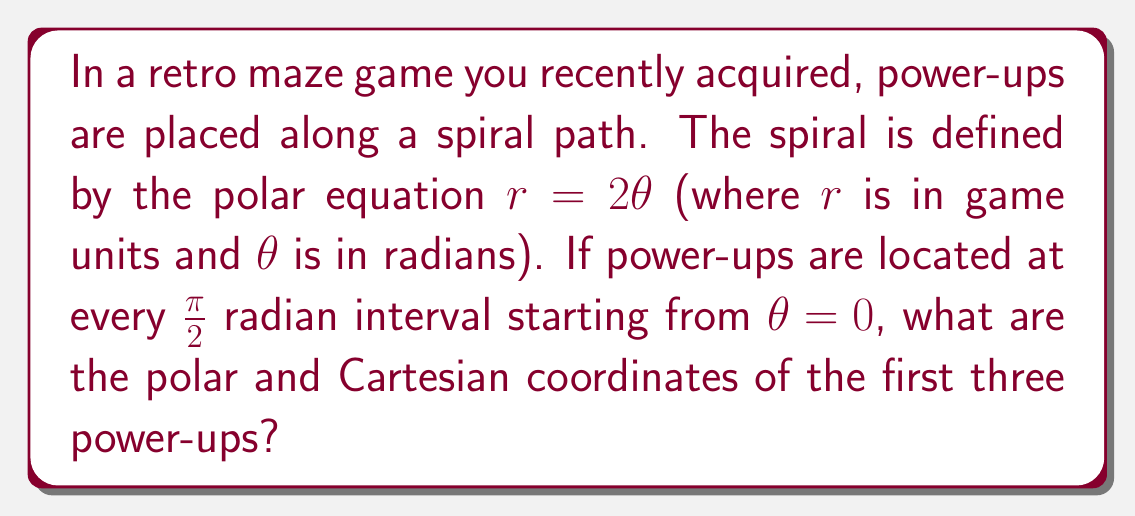Help me with this question. To solve this problem, we'll follow these steps:

1) First, we'll find the polar coordinates $(r, \theta)$ for each power-up:

   - For the first power-up: $\theta_1 = 0$
   - For the second power-up: $\theta_2 = \frac{\pi}{2}$
   - For the third power-up: $\theta_3 = \pi$

2) We'll use the equation $r = 2\theta$ to find the corresponding $r$ values:

   - For $\theta_1 = 0$: $r_1 = 2(0) = 0$
   - For $\theta_2 = \frac{\pi}{2}$: $r_2 = 2(\frac{\pi}{2}) = \pi$
   - For $\theta_3 = \pi$: $r_3 = 2(\pi) = 2\pi$

3) Now we have the polar coordinates:
   $(0, 0)$, $(\pi, \frac{\pi}{2})$, and $(2\pi, \pi)$

4) To convert these to Cartesian coordinates, we'll use the formulas:
   $x = r \cos(\theta)$ and $y = r \sin(\theta)$

   - For $(0, 0)$: 
     $x_1 = 0 \cos(0) = 0$, $y_1 = 0 \sin(0) = 0$

   - For $(\pi, \frac{\pi}{2})$:
     $x_2 = \pi \cos(\frac{\pi}{2}) = 0$, $y_2 = \pi \sin(\frac{\pi}{2}) = \pi$

   - For $(2\pi, \pi)$:
     $x_3 = 2\pi \cos(\pi) = -2\pi$, $y_3 = 2\pi \sin(\pi) = 0$

Therefore, the Cartesian coordinates are $(0, 0)$, $(0, \pi)$, and $(-2\pi, 0)$.
Answer: The coordinates of the first three power-ups are:

Polar: $(0, 0)$, $(\pi, \frac{\pi}{2})$, $(2\pi, \pi)$
Cartesian: $(0, 0)$, $(0, \pi)$, $(-2\pi, 0)$ 